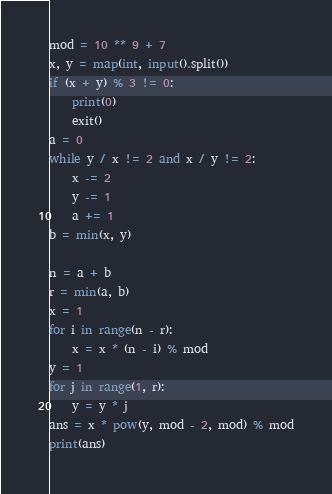<code> <loc_0><loc_0><loc_500><loc_500><_Python_>mod = 10 ** 9 + 7
x, y = map(int, input().split())
if (x + y) % 3 != 0:
    print(0)
    exit()
a = 0
while y / x != 2 and x / y != 2:
    x -= 2
    y -= 1
    a += 1
b = min(x, y)

n = a + b
r = min(a, b)
x = 1
for i in range(n - r):
    x = x * (n - i) % mod
y = 1
for j in range(1, r):
    y = y * j
ans = x * pow(y, mod - 2, mod) % mod
print(ans)
</code> 